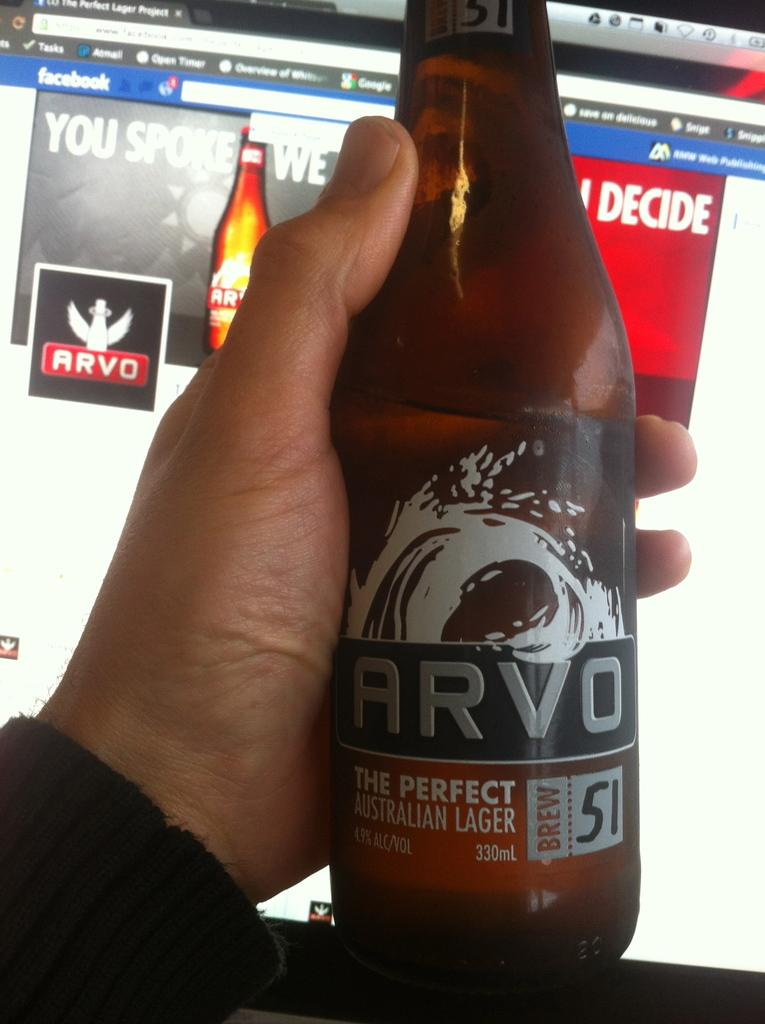Provide a one-sentence caption for the provided image. a brown bottle of Arvo perfect Australian lager in front of a facebook screen. 